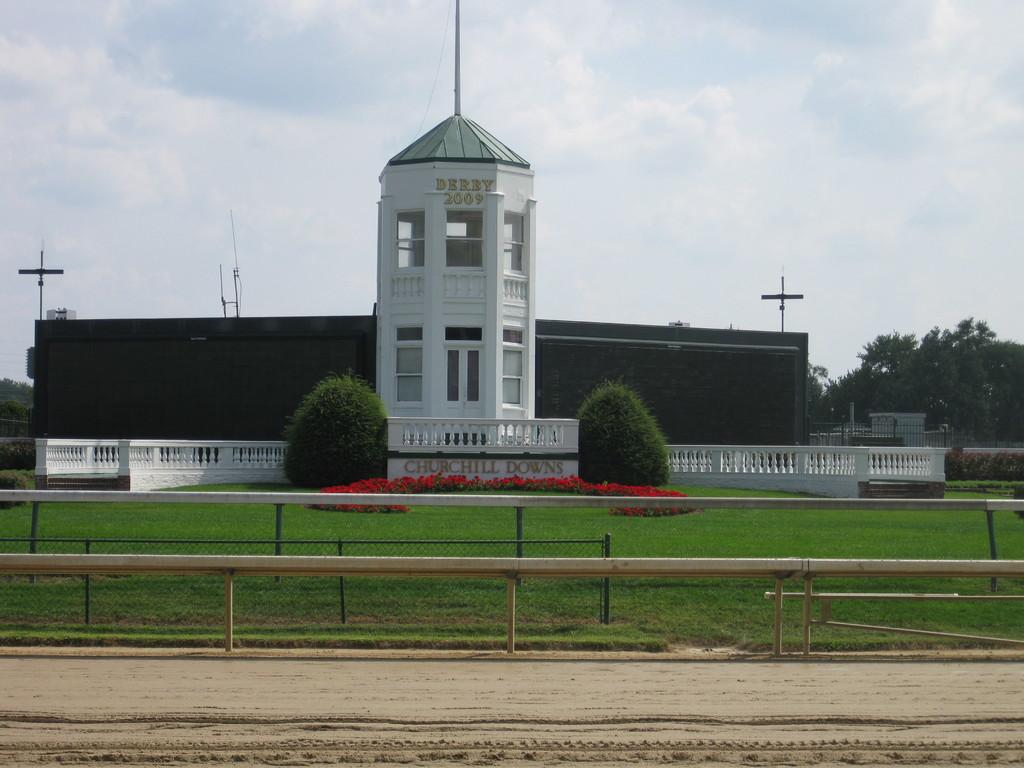What type of terrain is visible in the image? There is sand in the image. What type of barrier can be seen in the image? There is a fence in the image. What type of vegetation is present in the image? There is grass, flowers, and trees in the image. What type of structure is visible in the image? There is a building with windows in the image. What is visible in the background of the image? The sky is visible in the background of the image, with clouds present. What type of power is being generated by the sand in the image? There is no indication of power generation in the image; it simply shows sand as a part of the terrain. 